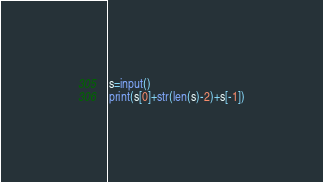<code> <loc_0><loc_0><loc_500><loc_500><_Python_>s=input()
print(s[0]+str(len(s)-2)+s[-1])</code> 